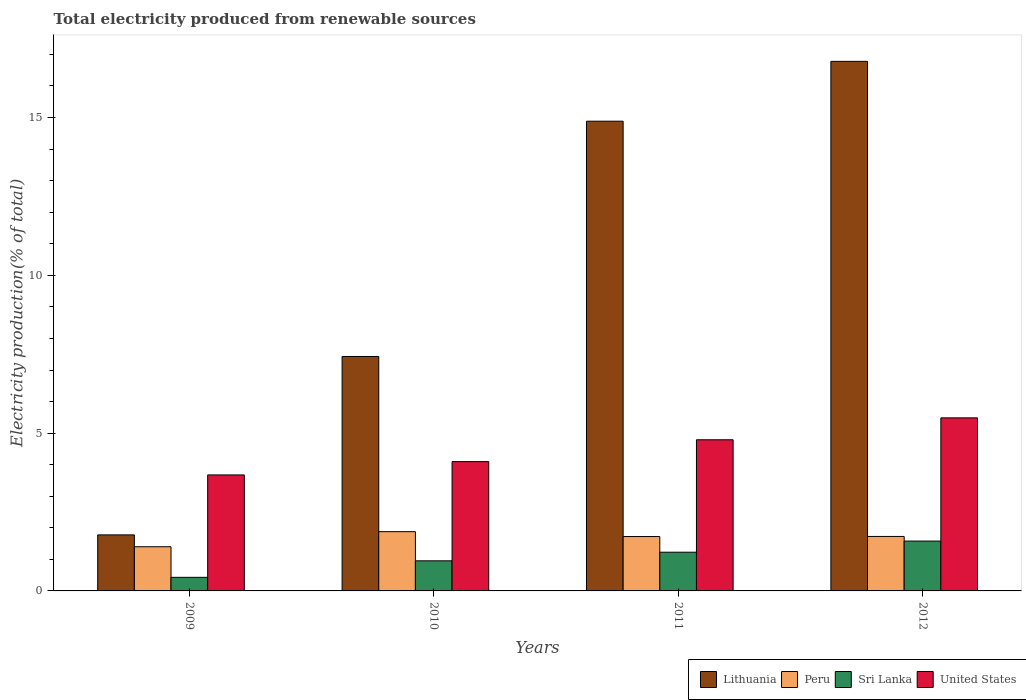How many different coloured bars are there?
Make the answer very short. 4. What is the label of the 4th group of bars from the left?
Provide a short and direct response. 2012. What is the total electricity produced in Lithuania in 2012?
Provide a succinct answer. 16.78. Across all years, what is the maximum total electricity produced in United States?
Your response must be concise. 5.48. Across all years, what is the minimum total electricity produced in Lithuania?
Your answer should be very brief. 1.78. What is the total total electricity produced in Lithuania in the graph?
Give a very brief answer. 40.87. What is the difference between the total electricity produced in Peru in 2011 and that in 2012?
Give a very brief answer. -0. What is the difference between the total electricity produced in Peru in 2011 and the total electricity produced in Lithuania in 2010?
Ensure brevity in your answer.  -5.71. What is the average total electricity produced in United States per year?
Your answer should be very brief. 4.51. In the year 2012, what is the difference between the total electricity produced in Peru and total electricity produced in Sri Lanka?
Give a very brief answer. 0.15. What is the ratio of the total electricity produced in Peru in 2009 to that in 2011?
Your answer should be very brief. 0.81. Is the total electricity produced in United States in 2009 less than that in 2010?
Provide a succinct answer. Yes. What is the difference between the highest and the second highest total electricity produced in Lithuania?
Offer a very short reply. 1.9. What is the difference between the highest and the lowest total electricity produced in Lithuania?
Ensure brevity in your answer.  15.01. Is the sum of the total electricity produced in Lithuania in 2010 and 2012 greater than the maximum total electricity produced in United States across all years?
Keep it short and to the point. Yes. What does the 3rd bar from the left in 2011 represents?
Offer a terse response. Sri Lanka. What does the 1st bar from the right in 2011 represents?
Keep it short and to the point. United States. How many bars are there?
Make the answer very short. 16. Are all the bars in the graph horizontal?
Keep it short and to the point. No. How many years are there in the graph?
Provide a short and direct response. 4. What is the difference between two consecutive major ticks on the Y-axis?
Ensure brevity in your answer.  5. Are the values on the major ticks of Y-axis written in scientific E-notation?
Offer a terse response. No. Does the graph contain grids?
Offer a very short reply. No. How are the legend labels stacked?
Keep it short and to the point. Horizontal. What is the title of the graph?
Keep it short and to the point. Total electricity produced from renewable sources. Does "East Asia (developing only)" appear as one of the legend labels in the graph?
Make the answer very short. No. What is the label or title of the X-axis?
Ensure brevity in your answer.  Years. What is the Electricity production(% of total) of Lithuania in 2009?
Make the answer very short. 1.78. What is the Electricity production(% of total) of Peru in 2009?
Make the answer very short. 1.4. What is the Electricity production(% of total) in Sri Lanka in 2009?
Your answer should be very brief. 0.43. What is the Electricity production(% of total) of United States in 2009?
Your answer should be compact. 3.68. What is the Electricity production(% of total) in Lithuania in 2010?
Your response must be concise. 7.43. What is the Electricity production(% of total) of Peru in 2010?
Offer a terse response. 1.88. What is the Electricity production(% of total) of Sri Lanka in 2010?
Your answer should be compact. 0.95. What is the Electricity production(% of total) of United States in 2010?
Ensure brevity in your answer.  4.1. What is the Electricity production(% of total) in Lithuania in 2011?
Ensure brevity in your answer.  14.88. What is the Electricity production(% of total) of Peru in 2011?
Offer a terse response. 1.72. What is the Electricity production(% of total) in Sri Lanka in 2011?
Offer a very short reply. 1.23. What is the Electricity production(% of total) of United States in 2011?
Provide a short and direct response. 4.79. What is the Electricity production(% of total) in Lithuania in 2012?
Provide a succinct answer. 16.78. What is the Electricity production(% of total) in Peru in 2012?
Make the answer very short. 1.73. What is the Electricity production(% of total) of Sri Lanka in 2012?
Your answer should be compact. 1.58. What is the Electricity production(% of total) in United States in 2012?
Your response must be concise. 5.48. Across all years, what is the maximum Electricity production(% of total) in Lithuania?
Your response must be concise. 16.78. Across all years, what is the maximum Electricity production(% of total) of Peru?
Your response must be concise. 1.88. Across all years, what is the maximum Electricity production(% of total) of Sri Lanka?
Keep it short and to the point. 1.58. Across all years, what is the maximum Electricity production(% of total) of United States?
Make the answer very short. 5.48. Across all years, what is the minimum Electricity production(% of total) in Lithuania?
Your response must be concise. 1.78. Across all years, what is the minimum Electricity production(% of total) of Peru?
Keep it short and to the point. 1.4. Across all years, what is the minimum Electricity production(% of total) of Sri Lanka?
Offer a very short reply. 0.43. Across all years, what is the minimum Electricity production(% of total) in United States?
Your answer should be very brief. 3.68. What is the total Electricity production(% of total) in Lithuania in the graph?
Provide a short and direct response. 40.87. What is the total Electricity production(% of total) in Peru in the graph?
Your response must be concise. 6.73. What is the total Electricity production(% of total) in Sri Lanka in the graph?
Ensure brevity in your answer.  4.19. What is the total Electricity production(% of total) of United States in the graph?
Make the answer very short. 18.05. What is the difference between the Electricity production(% of total) of Lithuania in 2009 and that in 2010?
Give a very brief answer. -5.65. What is the difference between the Electricity production(% of total) of Peru in 2009 and that in 2010?
Provide a succinct answer. -0.48. What is the difference between the Electricity production(% of total) in Sri Lanka in 2009 and that in 2010?
Your answer should be very brief. -0.52. What is the difference between the Electricity production(% of total) of United States in 2009 and that in 2010?
Your answer should be compact. -0.42. What is the difference between the Electricity production(% of total) in Lithuania in 2009 and that in 2011?
Make the answer very short. -13.11. What is the difference between the Electricity production(% of total) of Peru in 2009 and that in 2011?
Keep it short and to the point. -0.32. What is the difference between the Electricity production(% of total) of Sri Lanka in 2009 and that in 2011?
Your response must be concise. -0.8. What is the difference between the Electricity production(% of total) of United States in 2009 and that in 2011?
Keep it short and to the point. -1.11. What is the difference between the Electricity production(% of total) of Lithuania in 2009 and that in 2012?
Your answer should be compact. -15.01. What is the difference between the Electricity production(% of total) of Peru in 2009 and that in 2012?
Make the answer very short. -0.33. What is the difference between the Electricity production(% of total) in Sri Lanka in 2009 and that in 2012?
Ensure brevity in your answer.  -1.15. What is the difference between the Electricity production(% of total) in United States in 2009 and that in 2012?
Give a very brief answer. -1.81. What is the difference between the Electricity production(% of total) in Lithuania in 2010 and that in 2011?
Provide a short and direct response. -7.46. What is the difference between the Electricity production(% of total) of Peru in 2010 and that in 2011?
Make the answer very short. 0.15. What is the difference between the Electricity production(% of total) of Sri Lanka in 2010 and that in 2011?
Keep it short and to the point. -0.27. What is the difference between the Electricity production(% of total) of United States in 2010 and that in 2011?
Your response must be concise. -0.69. What is the difference between the Electricity production(% of total) in Lithuania in 2010 and that in 2012?
Offer a terse response. -9.35. What is the difference between the Electricity production(% of total) in Peru in 2010 and that in 2012?
Offer a terse response. 0.15. What is the difference between the Electricity production(% of total) of Sri Lanka in 2010 and that in 2012?
Give a very brief answer. -0.63. What is the difference between the Electricity production(% of total) of United States in 2010 and that in 2012?
Provide a short and direct response. -1.39. What is the difference between the Electricity production(% of total) in Lithuania in 2011 and that in 2012?
Your answer should be very brief. -1.9. What is the difference between the Electricity production(% of total) in Peru in 2011 and that in 2012?
Give a very brief answer. -0. What is the difference between the Electricity production(% of total) in Sri Lanka in 2011 and that in 2012?
Make the answer very short. -0.35. What is the difference between the Electricity production(% of total) of United States in 2011 and that in 2012?
Offer a very short reply. -0.69. What is the difference between the Electricity production(% of total) of Lithuania in 2009 and the Electricity production(% of total) of Peru in 2010?
Offer a terse response. -0.1. What is the difference between the Electricity production(% of total) in Lithuania in 2009 and the Electricity production(% of total) in Sri Lanka in 2010?
Make the answer very short. 0.82. What is the difference between the Electricity production(% of total) of Lithuania in 2009 and the Electricity production(% of total) of United States in 2010?
Offer a very short reply. -2.32. What is the difference between the Electricity production(% of total) in Peru in 2009 and the Electricity production(% of total) in Sri Lanka in 2010?
Ensure brevity in your answer.  0.45. What is the difference between the Electricity production(% of total) in Peru in 2009 and the Electricity production(% of total) in United States in 2010?
Provide a short and direct response. -2.7. What is the difference between the Electricity production(% of total) in Sri Lanka in 2009 and the Electricity production(% of total) in United States in 2010?
Make the answer very short. -3.67. What is the difference between the Electricity production(% of total) in Lithuania in 2009 and the Electricity production(% of total) in Peru in 2011?
Your response must be concise. 0.05. What is the difference between the Electricity production(% of total) of Lithuania in 2009 and the Electricity production(% of total) of Sri Lanka in 2011?
Offer a terse response. 0.55. What is the difference between the Electricity production(% of total) of Lithuania in 2009 and the Electricity production(% of total) of United States in 2011?
Provide a succinct answer. -3.01. What is the difference between the Electricity production(% of total) of Peru in 2009 and the Electricity production(% of total) of Sri Lanka in 2011?
Offer a terse response. 0.17. What is the difference between the Electricity production(% of total) of Peru in 2009 and the Electricity production(% of total) of United States in 2011?
Make the answer very short. -3.39. What is the difference between the Electricity production(% of total) of Sri Lanka in 2009 and the Electricity production(% of total) of United States in 2011?
Offer a very short reply. -4.36. What is the difference between the Electricity production(% of total) in Lithuania in 2009 and the Electricity production(% of total) in Peru in 2012?
Provide a succinct answer. 0.05. What is the difference between the Electricity production(% of total) of Lithuania in 2009 and the Electricity production(% of total) of Sri Lanka in 2012?
Offer a terse response. 0.2. What is the difference between the Electricity production(% of total) of Lithuania in 2009 and the Electricity production(% of total) of United States in 2012?
Your response must be concise. -3.71. What is the difference between the Electricity production(% of total) of Peru in 2009 and the Electricity production(% of total) of Sri Lanka in 2012?
Keep it short and to the point. -0.18. What is the difference between the Electricity production(% of total) in Peru in 2009 and the Electricity production(% of total) in United States in 2012?
Provide a short and direct response. -4.08. What is the difference between the Electricity production(% of total) in Sri Lanka in 2009 and the Electricity production(% of total) in United States in 2012?
Provide a short and direct response. -5.05. What is the difference between the Electricity production(% of total) of Lithuania in 2010 and the Electricity production(% of total) of Peru in 2011?
Offer a terse response. 5.71. What is the difference between the Electricity production(% of total) in Lithuania in 2010 and the Electricity production(% of total) in Sri Lanka in 2011?
Give a very brief answer. 6.2. What is the difference between the Electricity production(% of total) of Lithuania in 2010 and the Electricity production(% of total) of United States in 2011?
Offer a terse response. 2.64. What is the difference between the Electricity production(% of total) of Peru in 2010 and the Electricity production(% of total) of Sri Lanka in 2011?
Provide a succinct answer. 0.65. What is the difference between the Electricity production(% of total) of Peru in 2010 and the Electricity production(% of total) of United States in 2011?
Your answer should be very brief. -2.91. What is the difference between the Electricity production(% of total) in Sri Lanka in 2010 and the Electricity production(% of total) in United States in 2011?
Provide a short and direct response. -3.84. What is the difference between the Electricity production(% of total) in Lithuania in 2010 and the Electricity production(% of total) in Peru in 2012?
Provide a short and direct response. 5.7. What is the difference between the Electricity production(% of total) in Lithuania in 2010 and the Electricity production(% of total) in Sri Lanka in 2012?
Provide a short and direct response. 5.85. What is the difference between the Electricity production(% of total) in Lithuania in 2010 and the Electricity production(% of total) in United States in 2012?
Offer a terse response. 1.95. What is the difference between the Electricity production(% of total) in Peru in 2010 and the Electricity production(% of total) in Sri Lanka in 2012?
Your response must be concise. 0.3. What is the difference between the Electricity production(% of total) of Peru in 2010 and the Electricity production(% of total) of United States in 2012?
Your answer should be compact. -3.61. What is the difference between the Electricity production(% of total) in Sri Lanka in 2010 and the Electricity production(% of total) in United States in 2012?
Give a very brief answer. -4.53. What is the difference between the Electricity production(% of total) in Lithuania in 2011 and the Electricity production(% of total) in Peru in 2012?
Offer a terse response. 13.16. What is the difference between the Electricity production(% of total) of Lithuania in 2011 and the Electricity production(% of total) of Sri Lanka in 2012?
Offer a terse response. 13.3. What is the difference between the Electricity production(% of total) of Lithuania in 2011 and the Electricity production(% of total) of United States in 2012?
Ensure brevity in your answer.  9.4. What is the difference between the Electricity production(% of total) in Peru in 2011 and the Electricity production(% of total) in Sri Lanka in 2012?
Keep it short and to the point. 0.14. What is the difference between the Electricity production(% of total) of Peru in 2011 and the Electricity production(% of total) of United States in 2012?
Keep it short and to the point. -3.76. What is the difference between the Electricity production(% of total) of Sri Lanka in 2011 and the Electricity production(% of total) of United States in 2012?
Your response must be concise. -4.26. What is the average Electricity production(% of total) in Lithuania per year?
Your answer should be compact. 10.22. What is the average Electricity production(% of total) of Peru per year?
Your answer should be very brief. 1.68. What is the average Electricity production(% of total) in Sri Lanka per year?
Offer a very short reply. 1.05. What is the average Electricity production(% of total) of United States per year?
Keep it short and to the point. 4.51. In the year 2009, what is the difference between the Electricity production(% of total) of Lithuania and Electricity production(% of total) of Peru?
Provide a succinct answer. 0.38. In the year 2009, what is the difference between the Electricity production(% of total) in Lithuania and Electricity production(% of total) in Sri Lanka?
Keep it short and to the point. 1.34. In the year 2009, what is the difference between the Electricity production(% of total) of Lithuania and Electricity production(% of total) of United States?
Your answer should be very brief. -1.9. In the year 2009, what is the difference between the Electricity production(% of total) of Peru and Electricity production(% of total) of Sri Lanka?
Your response must be concise. 0.97. In the year 2009, what is the difference between the Electricity production(% of total) in Peru and Electricity production(% of total) in United States?
Give a very brief answer. -2.28. In the year 2009, what is the difference between the Electricity production(% of total) in Sri Lanka and Electricity production(% of total) in United States?
Give a very brief answer. -3.25. In the year 2010, what is the difference between the Electricity production(% of total) in Lithuania and Electricity production(% of total) in Peru?
Keep it short and to the point. 5.55. In the year 2010, what is the difference between the Electricity production(% of total) of Lithuania and Electricity production(% of total) of Sri Lanka?
Offer a terse response. 6.48. In the year 2010, what is the difference between the Electricity production(% of total) in Lithuania and Electricity production(% of total) in United States?
Keep it short and to the point. 3.33. In the year 2010, what is the difference between the Electricity production(% of total) in Peru and Electricity production(% of total) in Sri Lanka?
Provide a short and direct response. 0.92. In the year 2010, what is the difference between the Electricity production(% of total) of Peru and Electricity production(% of total) of United States?
Give a very brief answer. -2.22. In the year 2010, what is the difference between the Electricity production(% of total) in Sri Lanka and Electricity production(% of total) in United States?
Provide a succinct answer. -3.14. In the year 2011, what is the difference between the Electricity production(% of total) of Lithuania and Electricity production(% of total) of Peru?
Your response must be concise. 13.16. In the year 2011, what is the difference between the Electricity production(% of total) in Lithuania and Electricity production(% of total) in Sri Lanka?
Give a very brief answer. 13.66. In the year 2011, what is the difference between the Electricity production(% of total) in Lithuania and Electricity production(% of total) in United States?
Make the answer very short. 10.1. In the year 2011, what is the difference between the Electricity production(% of total) of Peru and Electricity production(% of total) of Sri Lanka?
Provide a short and direct response. 0.5. In the year 2011, what is the difference between the Electricity production(% of total) in Peru and Electricity production(% of total) in United States?
Make the answer very short. -3.07. In the year 2011, what is the difference between the Electricity production(% of total) in Sri Lanka and Electricity production(% of total) in United States?
Give a very brief answer. -3.56. In the year 2012, what is the difference between the Electricity production(% of total) of Lithuania and Electricity production(% of total) of Peru?
Your answer should be compact. 15.05. In the year 2012, what is the difference between the Electricity production(% of total) in Lithuania and Electricity production(% of total) in Sri Lanka?
Your response must be concise. 15.2. In the year 2012, what is the difference between the Electricity production(% of total) in Lithuania and Electricity production(% of total) in United States?
Give a very brief answer. 11.3. In the year 2012, what is the difference between the Electricity production(% of total) in Peru and Electricity production(% of total) in Sri Lanka?
Offer a very short reply. 0.15. In the year 2012, what is the difference between the Electricity production(% of total) in Peru and Electricity production(% of total) in United States?
Offer a terse response. -3.76. In the year 2012, what is the difference between the Electricity production(% of total) of Sri Lanka and Electricity production(% of total) of United States?
Ensure brevity in your answer.  -3.9. What is the ratio of the Electricity production(% of total) of Lithuania in 2009 to that in 2010?
Provide a short and direct response. 0.24. What is the ratio of the Electricity production(% of total) in Peru in 2009 to that in 2010?
Your answer should be compact. 0.75. What is the ratio of the Electricity production(% of total) in Sri Lanka in 2009 to that in 2010?
Provide a succinct answer. 0.45. What is the ratio of the Electricity production(% of total) in United States in 2009 to that in 2010?
Keep it short and to the point. 0.9. What is the ratio of the Electricity production(% of total) of Lithuania in 2009 to that in 2011?
Provide a succinct answer. 0.12. What is the ratio of the Electricity production(% of total) of Peru in 2009 to that in 2011?
Your response must be concise. 0.81. What is the ratio of the Electricity production(% of total) of Sri Lanka in 2009 to that in 2011?
Give a very brief answer. 0.35. What is the ratio of the Electricity production(% of total) in United States in 2009 to that in 2011?
Make the answer very short. 0.77. What is the ratio of the Electricity production(% of total) in Lithuania in 2009 to that in 2012?
Keep it short and to the point. 0.11. What is the ratio of the Electricity production(% of total) in Peru in 2009 to that in 2012?
Keep it short and to the point. 0.81. What is the ratio of the Electricity production(% of total) of Sri Lanka in 2009 to that in 2012?
Make the answer very short. 0.27. What is the ratio of the Electricity production(% of total) of United States in 2009 to that in 2012?
Offer a terse response. 0.67. What is the ratio of the Electricity production(% of total) of Lithuania in 2010 to that in 2011?
Your answer should be very brief. 0.5. What is the ratio of the Electricity production(% of total) in Peru in 2010 to that in 2011?
Offer a terse response. 1.09. What is the ratio of the Electricity production(% of total) in Sri Lanka in 2010 to that in 2011?
Make the answer very short. 0.78. What is the ratio of the Electricity production(% of total) in United States in 2010 to that in 2011?
Offer a very short reply. 0.86. What is the ratio of the Electricity production(% of total) of Lithuania in 2010 to that in 2012?
Keep it short and to the point. 0.44. What is the ratio of the Electricity production(% of total) of Peru in 2010 to that in 2012?
Offer a very short reply. 1.09. What is the ratio of the Electricity production(% of total) in Sri Lanka in 2010 to that in 2012?
Provide a short and direct response. 0.6. What is the ratio of the Electricity production(% of total) of United States in 2010 to that in 2012?
Make the answer very short. 0.75. What is the ratio of the Electricity production(% of total) in Lithuania in 2011 to that in 2012?
Keep it short and to the point. 0.89. What is the ratio of the Electricity production(% of total) in Sri Lanka in 2011 to that in 2012?
Offer a very short reply. 0.78. What is the ratio of the Electricity production(% of total) in United States in 2011 to that in 2012?
Keep it short and to the point. 0.87. What is the difference between the highest and the second highest Electricity production(% of total) of Lithuania?
Your answer should be compact. 1.9. What is the difference between the highest and the second highest Electricity production(% of total) of Peru?
Ensure brevity in your answer.  0.15. What is the difference between the highest and the second highest Electricity production(% of total) of Sri Lanka?
Offer a very short reply. 0.35. What is the difference between the highest and the second highest Electricity production(% of total) in United States?
Give a very brief answer. 0.69. What is the difference between the highest and the lowest Electricity production(% of total) of Lithuania?
Provide a succinct answer. 15.01. What is the difference between the highest and the lowest Electricity production(% of total) in Peru?
Offer a terse response. 0.48. What is the difference between the highest and the lowest Electricity production(% of total) in Sri Lanka?
Provide a short and direct response. 1.15. What is the difference between the highest and the lowest Electricity production(% of total) of United States?
Your answer should be compact. 1.81. 